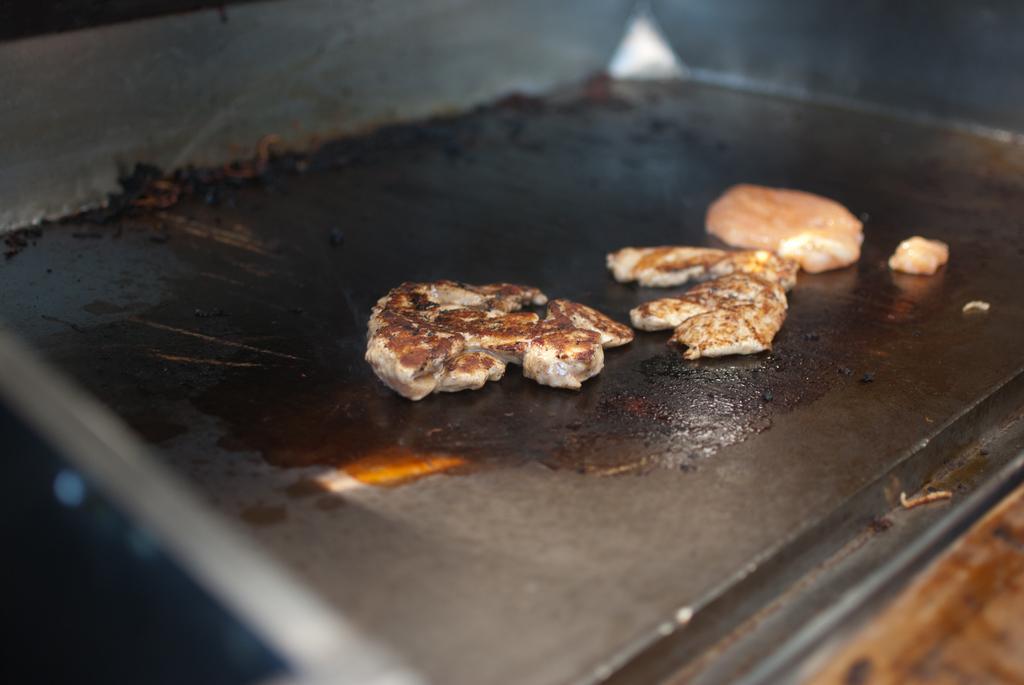Describe this image in one or two sentences. In the picture we can see a tray with a black in color and some cookies on it. 